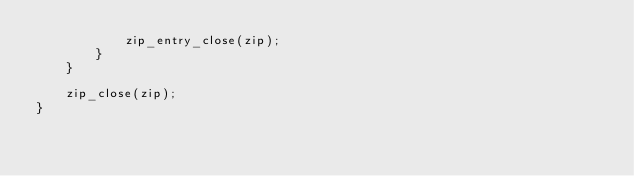<code> <loc_0><loc_0><loc_500><loc_500><_C++_>            zip_entry_close(zip);
        }
    }

    zip_close(zip);
}</code> 